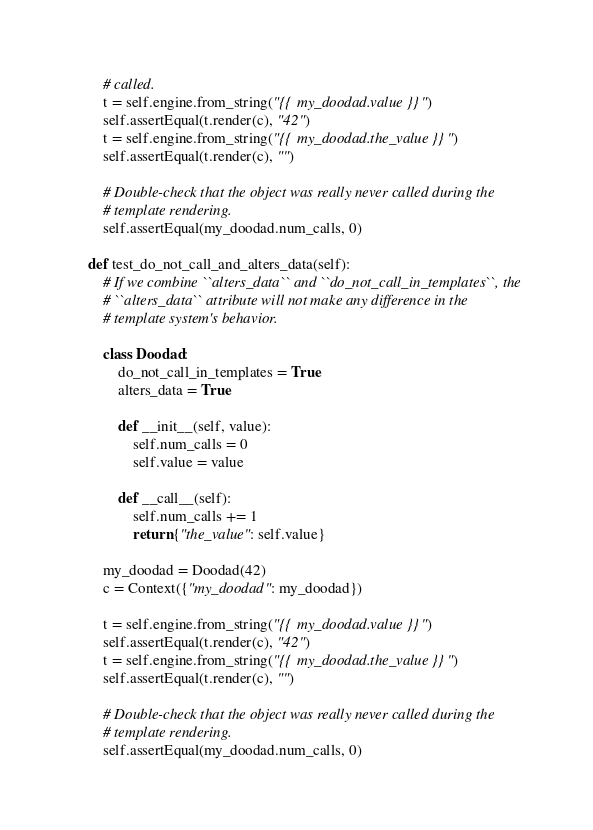Convert code to text. <code><loc_0><loc_0><loc_500><loc_500><_Python_>        # called.
        t = self.engine.from_string("{{ my_doodad.value }}")
        self.assertEqual(t.render(c), "42")
        t = self.engine.from_string("{{ my_doodad.the_value }}")
        self.assertEqual(t.render(c), "")

        # Double-check that the object was really never called during the
        # template rendering.
        self.assertEqual(my_doodad.num_calls, 0)

    def test_do_not_call_and_alters_data(self):
        # If we combine ``alters_data`` and ``do_not_call_in_templates``, the
        # ``alters_data`` attribute will not make any difference in the
        # template system's behavior.

        class Doodad:
            do_not_call_in_templates = True
            alters_data = True

            def __init__(self, value):
                self.num_calls = 0
                self.value = value

            def __call__(self):
                self.num_calls += 1
                return {"the_value": self.value}

        my_doodad = Doodad(42)
        c = Context({"my_doodad": my_doodad})

        t = self.engine.from_string("{{ my_doodad.value }}")
        self.assertEqual(t.render(c), "42")
        t = self.engine.from_string("{{ my_doodad.the_value }}")
        self.assertEqual(t.render(c), "")

        # Double-check that the object was really never called during the
        # template rendering.
        self.assertEqual(my_doodad.num_calls, 0)
</code> 